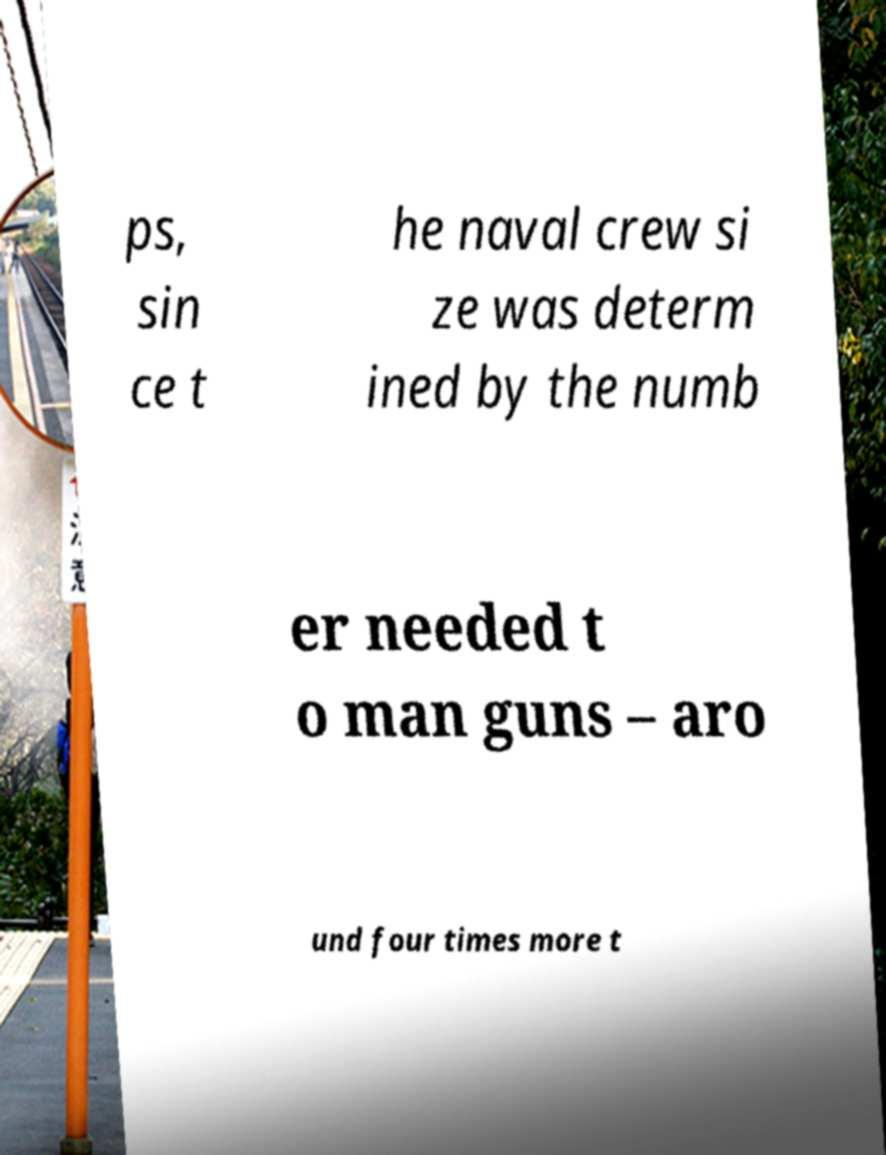What messages or text are displayed in this image? I need them in a readable, typed format. ps, sin ce t he naval crew si ze was determ ined by the numb er needed t o man guns – aro und four times more t 